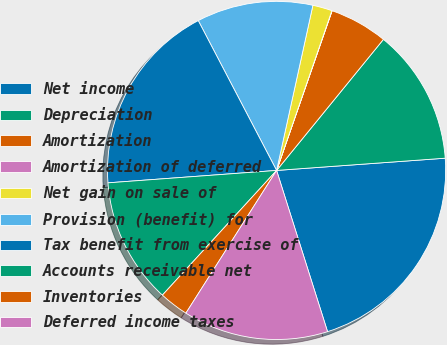Convert chart to OTSL. <chart><loc_0><loc_0><loc_500><loc_500><pie_chart><fcel>Net income<fcel>Depreciation<fcel>Amortization<fcel>Amortization of deferred<fcel>Net gain on sale of<fcel>Provision (benefit) for<fcel>Tax benefit from exercise of<fcel>Accounts receivable net<fcel>Inventories<fcel>Deferred income taxes<nl><fcel>21.28%<fcel>12.96%<fcel>5.56%<fcel>0.02%<fcel>1.86%<fcel>11.11%<fcel>18.5%<fcel>12.03%<fcel>2.79%<fcel>13.88%<nl></chart> 